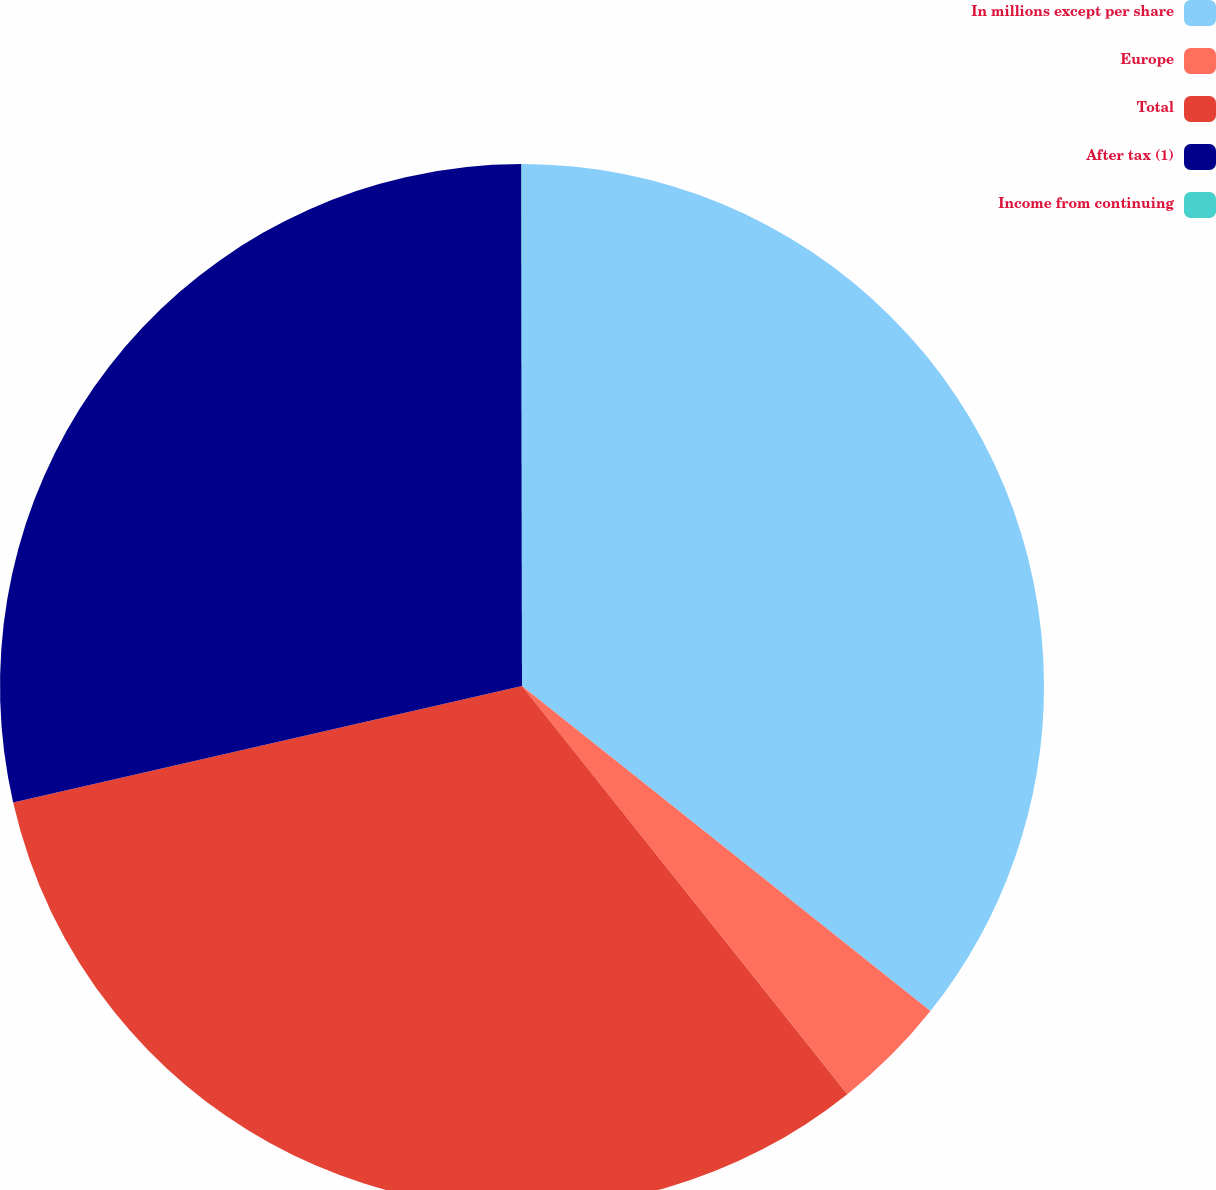Convert chart to OTSL. <chart><loc_0><loc_0><loc_500><loc_500><pie_chart><fcel>In millions except per share<fcel>Europe<fcel>Total<fcel>After tax (1)<fcel>Income from continuing<nl><fcel>35.7%<fcel>3.59%<fcel>32.13%<fcel>28.56%<fcel>0.02%<nl></chart> 